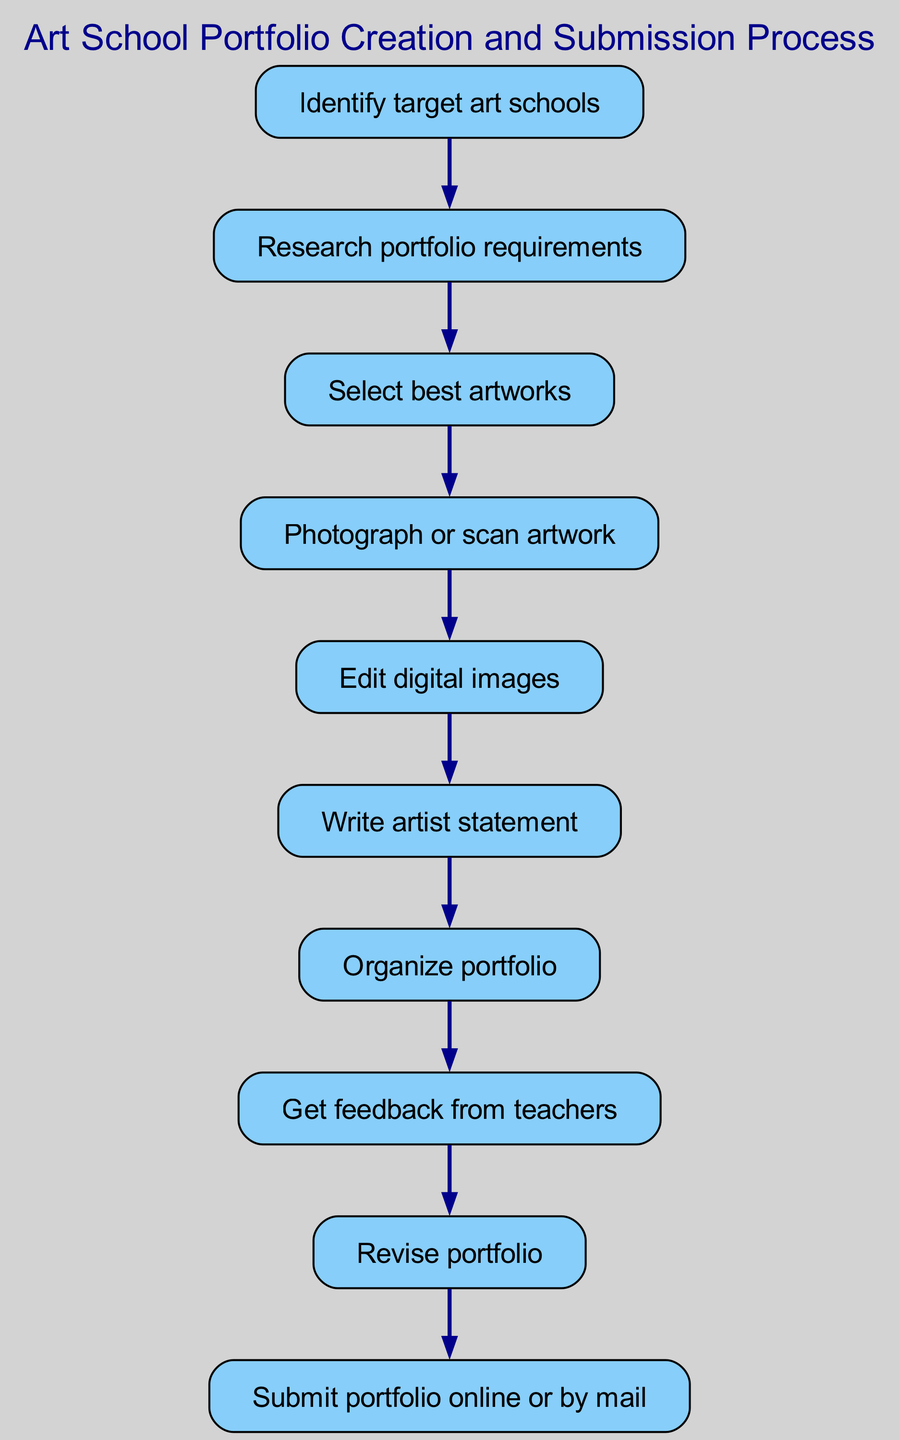What is the first step in the portfolio creation process? The first step in the process is clearly stated in the diagram as "Identify target art schools." Since this is the initial node in the flowchart, it serves as the starting point for the entire process.
Answer: Identify target art schools How many steps are there in the diagram? To find the number of steps, I will count the individual nodes in the diagram. Each step corresponds with a unique node from step 1 to step 10. Counting all these nodes gives me a total of 10 steps.
Answer: 10 What comes after writing the artist statement? The flowchart shows that the step that follows "Write artist statement" is "Organize portfolio." This direct link indicates the sequential order of actions.
Answer: Organize portfolio What is the final action in the diagram? Looking at the last node connected in the flowchart, the final action is "Submit portfolio online or by mail." This is the last step before the process concludes.
Answer: Submit portfolio online or by mail Which step involves getting feedback? From the flowchart, the step dedicated to obtaining feedback is labeled "Get feedback from teachers." This node specifically outlines an essential part of the process where feedback is sought.
Answer: Get feedback from teachers What is the relationship between selecting best artworks and photographing/scanning artwork? In the diagram, the relationship shows that "Select best artworks" leads directly to "Photograph or scan artwork." This indicates that choosing the artworks is a prerequisite for the photographing or scanning process, establishing a clear sequence.
Answer: Selecting best artworks leads to photographing/scanning artwork What is the purpose of revising the portfolio? The diagram indirectly defines the purpose of "Revise portfolio" through its placement after "Get feedback from teachers." This suggests that the revision process is essential for incorporating the feedback received, ensuring the portfolio aligns with expectations.
Answer: To incorporate feedback received How many edges are in the diagram? To determine the number of edges, I will count the connections between each step from the first to the last node. Since there are 10 steps, and each step (except the last) connects to the next, there are 9 edges linking them together.
Answer: 9 Which step directly follows organizing the portfolio? Examining the flowchart, the step that comes immediately after "Organize portfolio" is "Get feedback from teachers." This indicates the logical flow from organization to feedback gathering.
Answer: Get feedback from teachers 